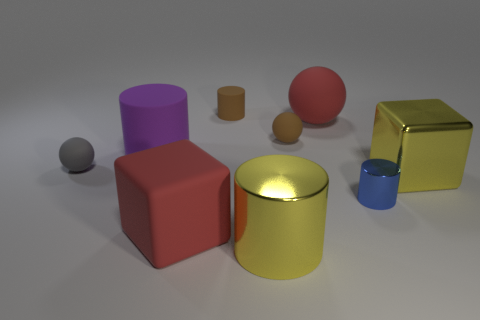What does the selection of objects and their presentation suggest about the purpose of the image? The deliberate placement of geometric shapes in varying colors and sizes suggests an artistic or educational purpose, such as to study geometry, color theory, or lighting effects in a controlled setting. The diversity among the objects implies a designed scenario, possibly to demonstrate 3D modeling, rendering techniques, or for a visual composition exercise in a digital or artistic learning context. 